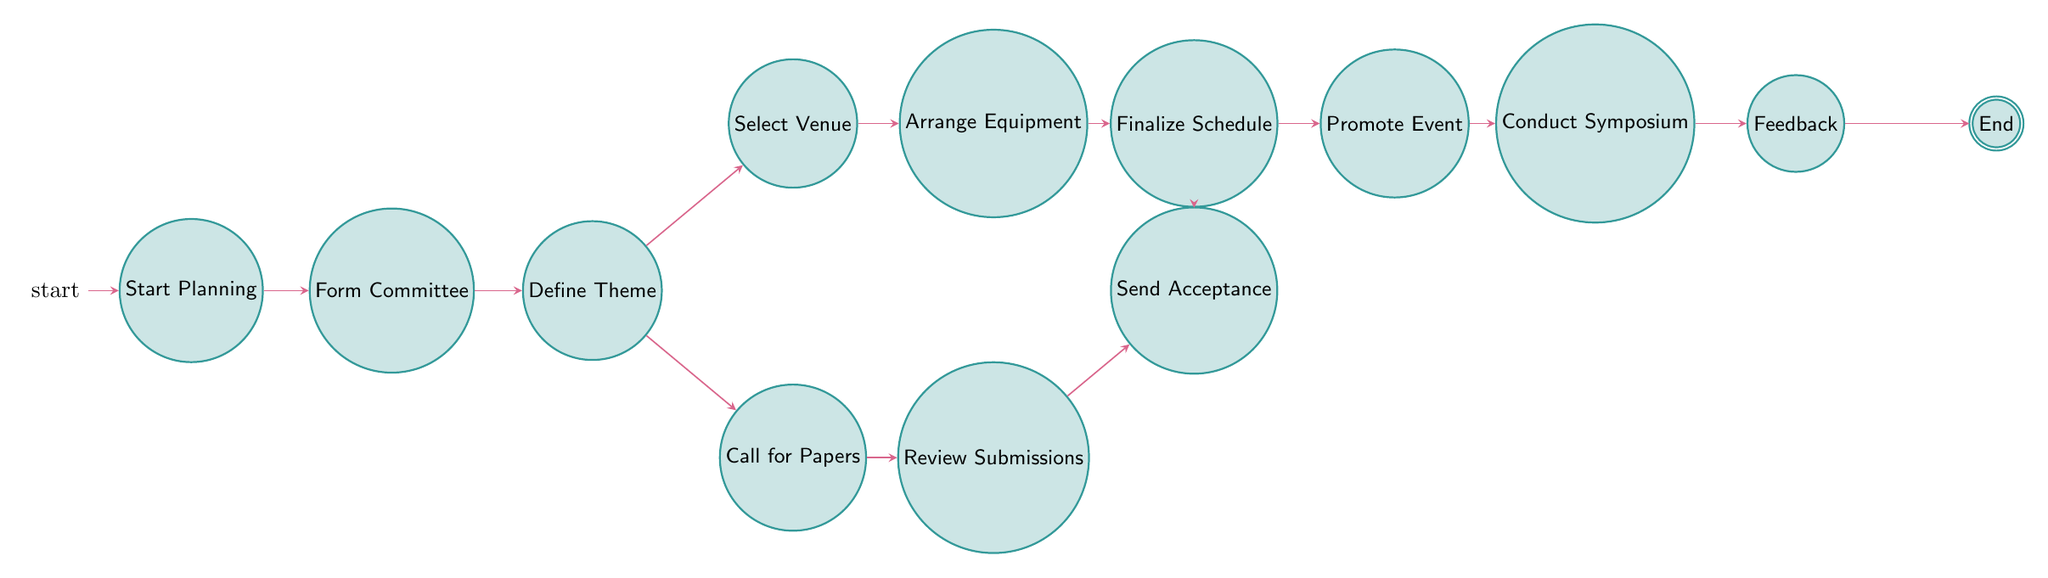What is the first step in the diagram? The diagram starts with the state labeled "Start Planning." This is the initial node from which all transitions originate.
Answer: Start Planning How many total states are in the diagram? By counting each distinct state listed in the diagram, we find there are 13 states present.
Answer: 13 What is the state that follows "Form Organizing Committee"? According to the transitions from the state "Form Committee," it leads directly to the next state, which is "Define Symposium Theme."
Answer: Define Symposium Theme Which state allows two different transitions? The state "Define Symposium Theme" has two outgoing transitions, pointing to the states "Select Venue" and "Call for Papers," setting it apart from the other states that typically have one transition.
Answer: Define Symposium Theme What is the last step before reaching "End"? The state "Feedback and Evaluation" is the last actionable stage before transitioning to the final state, "End." This indicates that feedback is collected right before concluding the process.
Answer: Feedback and Evaluation What are the two activities that can occur after defining the symposium theme? After "Define Symposium Theme," the diagram shows two possible activities: "Select Venue" and "Call for Papers," indicating that planning can go in different directions from this state.
Answer: Select Venue, Call for Papers What is the only state that transitions directly to "End"? The "Feedback and Evaluation" state has the unique characteristic of transitioning directly to "End," concluding the entire sequence of events in the diagram.
Answer: Feedback and Evaluation Which step comes directly after the “Finalize Schedule”? After "Finalize Schedule," the process transitions to "Promote Event," showcasing the flow toward disseminating information about the symposium.
Answer: Promote Event How many directions can "Call for Papers" transition? From "Call for Papers," there is only one transition option, which goes to "Review Submissions," confirming that this state leads to a single next step in the process.
Answer: 1 